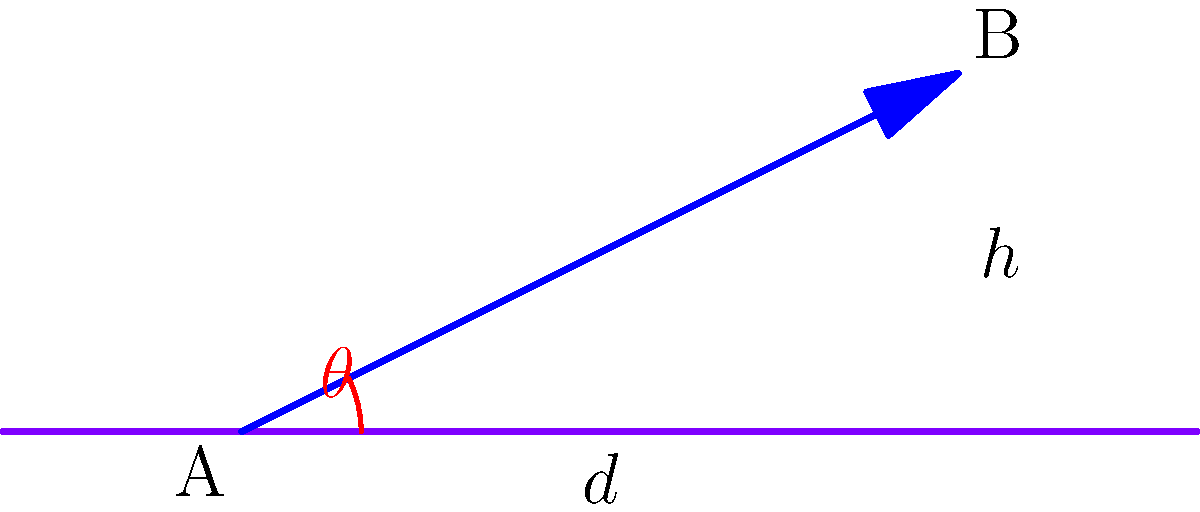An ARM-based IoT device needs to be placed at point A to communicate with a receiver at point B. The horizontal distance between A and B is $d = 60$ meters, and the height difference is $h = 30$ meters. What is the angle of elevation $\theta$ (in degrees) that the antenna should be positioned at to maximize signal strength? To find the angle of elevation $\theta$, we can use the arctangent function, as this problem involves a right triangle. Here's the step-by-step solution:

1) In the right triangle formed by points A and B:
   - The adjacent side is the horizontal distance $d = 60$ meters
   - The opposite side is the height difference $h = 30$ meters

2) The tangent of the angle $\theta$ is the ratio of the opposite side to the adjacent side:

   $$\tan(\theta) = \frac{\text{opposite}}{\text{adjacent}} = \frac{h}{d} = \frac{30}{60} = \frac{1}{2}$$

3) To find $\theta$, we need to take the inverse tangent (arctangent) of this ratio:

   $$\theta = \arctan(\frac{1}{2})$$

4) Using a calculator or programming function to evaluate this:

   $$\theta \approx 26.57^\circ$$

5) Round to two decimal places for the final answer.

This angle will provide the direct line-of-sight path between the antenna and the receiver, maximizing signal strength.
Answer: $26.57^\circ$ 